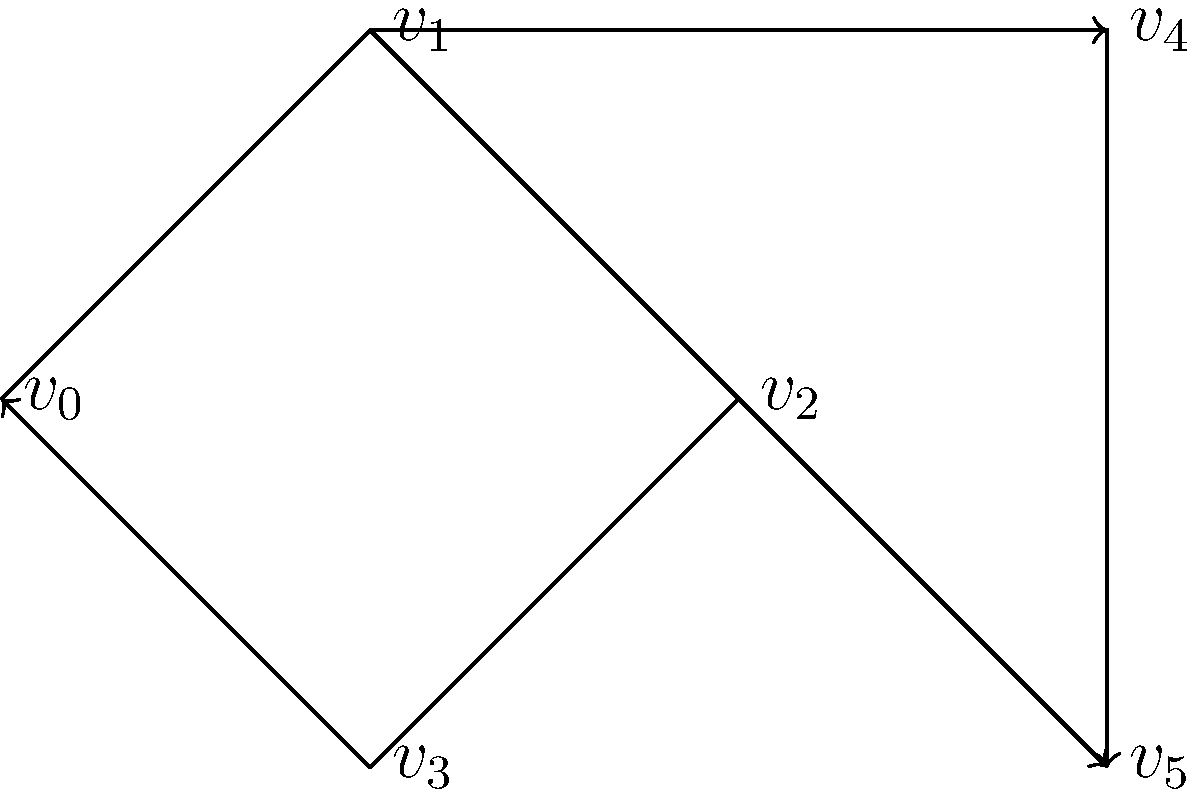As a software engineer working with the TFS API, you're tasked with implementing a cycle detection algorithm for an undirected graph. Given the graph above, how many unique cycles does it contain? (Note: A cycle that visits the same set of vertices in a different order is considered the same cycle.) To solve this problem, we'll use a systematic approach to identify all unique cycles in the graph:

1. First, we need to understand what constitutes a cycle in an undirected graph. A cycle is a path that starts and ends at the same vertex, with no repeated edges.

2. We'll examine the graph vertex by vertex:

   a) Starting from $v_0$:
      - $v_0 \rightarrow v_1 \rightarrow v_2 \rightarrow v_3 \rightarrow v_0$ (Cycle 1)

   b) Starting from $v_1$:
      - $v_1 \rightarrow v_2 \rightarrow v_3 \rightarrow v_0 \rightarrow v_1$ (same as Cycle 1)
      - $v_1 \rightarrow v_4 \rightarrow v_5 \rightarrow v_2 \rightarrow v_1$ (Cycle 2)

   c) Starting from $v_2$:
      - $v_2 \rightarrow v_3 \rightarrow v_0 \rightarrow v_1 \rightarrow v_2$ (same as Cycle 1)
      - $v_2 \rightarrow v_5 \rightarrow v_4 \rightarrow v_1 \rightarrow v_2$ (same as Cycle 2)

   d) Starting from $v_3$, $v_4$, and $v_5$:
      - No new cycles are found that haven't been identified already.

3. We've identified two unique cycles:
   - Cycle 1: $v_0 \rightarrow v_1 \rightarrow v_2 \rightarrow v_3 \rightarrow v_0$
   - Cycle 2: $v_1 \rightarrow v_4 \rightarrow v_5 \rightarrow v_2 \rightarrow v_1$

Therefore, the graph contains 2 unique cycles.
Answer: 2 